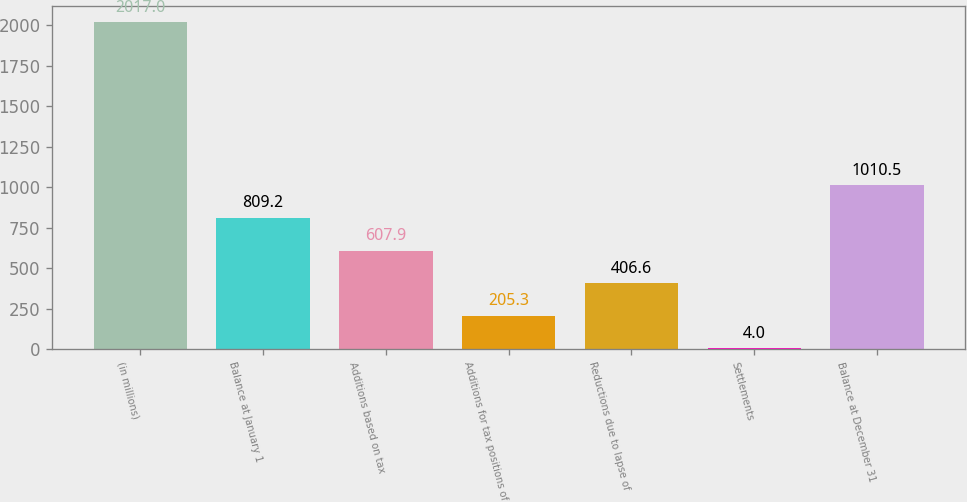Convert chart. <chart><loc_0><loc_0><loc_500><loc_500><bar_chart><fcel>(in millions)<fcel>Balance at January 1<fcel>Additions based on tax<fcel>Additions for tax positions of<fcel>Reductions due to lapse of<fcel>Settlements<fcel>Balance at December 31<nl><fcel>2017<fcel>809.2<fcel>607.9<fcel>205.3<fcel>406.6<fcel>4<fcel>1010.5<nl></chart> 